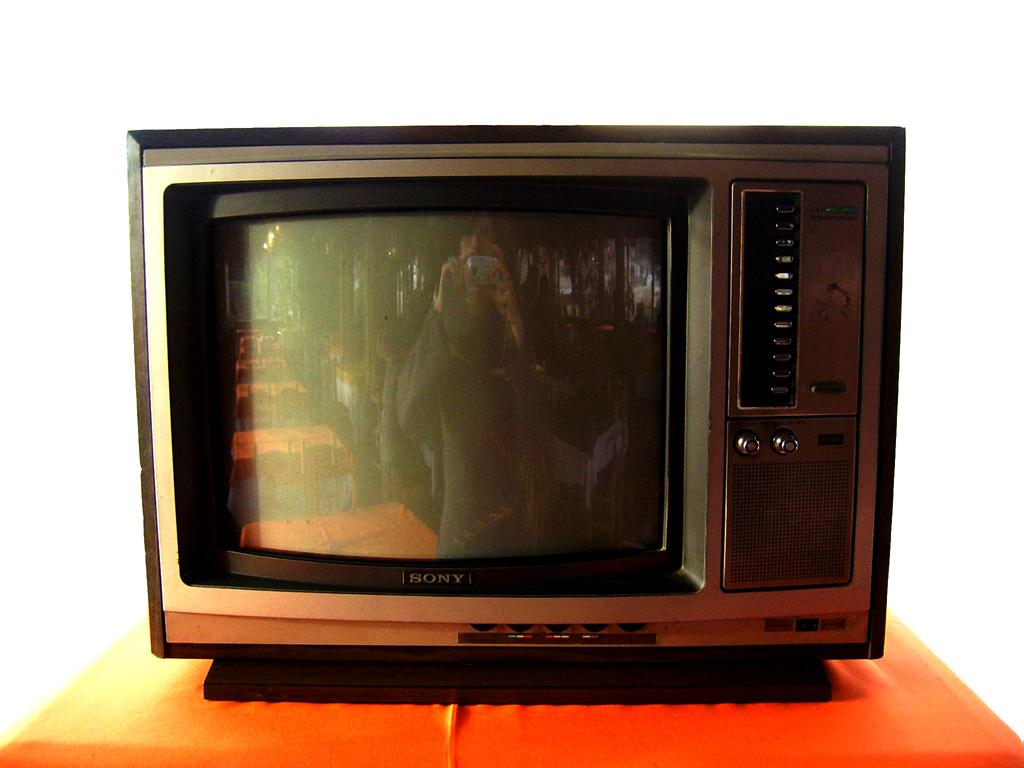Provide a one-sentence caption for the provided image. An old fashioned Sony TV on an orange table. 